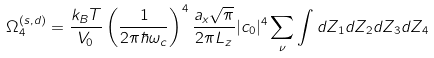Convert formula to latex. <formula><loc_0><loc_0><loc_500><loc_500>\Omega _ { 4 } ^ { ( s , d ) } = \frac { k _ { B } T } { V _ { 0 } } \left ( \frac { 1 } { 2 \pi \hbar { \omega } _ { c } } \right ) ^ { 4 } \frac { a _ { x } \sqrt { \pi } } { 2 \pi L _ { z } } | c _ { 0 } | ^ { 4 } \sum _ { \nu } \int d Z _ { 1 } d Z _ { 2 } d Z _ { 3 } d Z _ { 4 }</formula> 